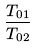Convert formula to latex. <formula><loc_0><loc_0><loc_500><loc_500>\frac { T _ { 0 1 } } { T _ { 0 2 } }</formula> 